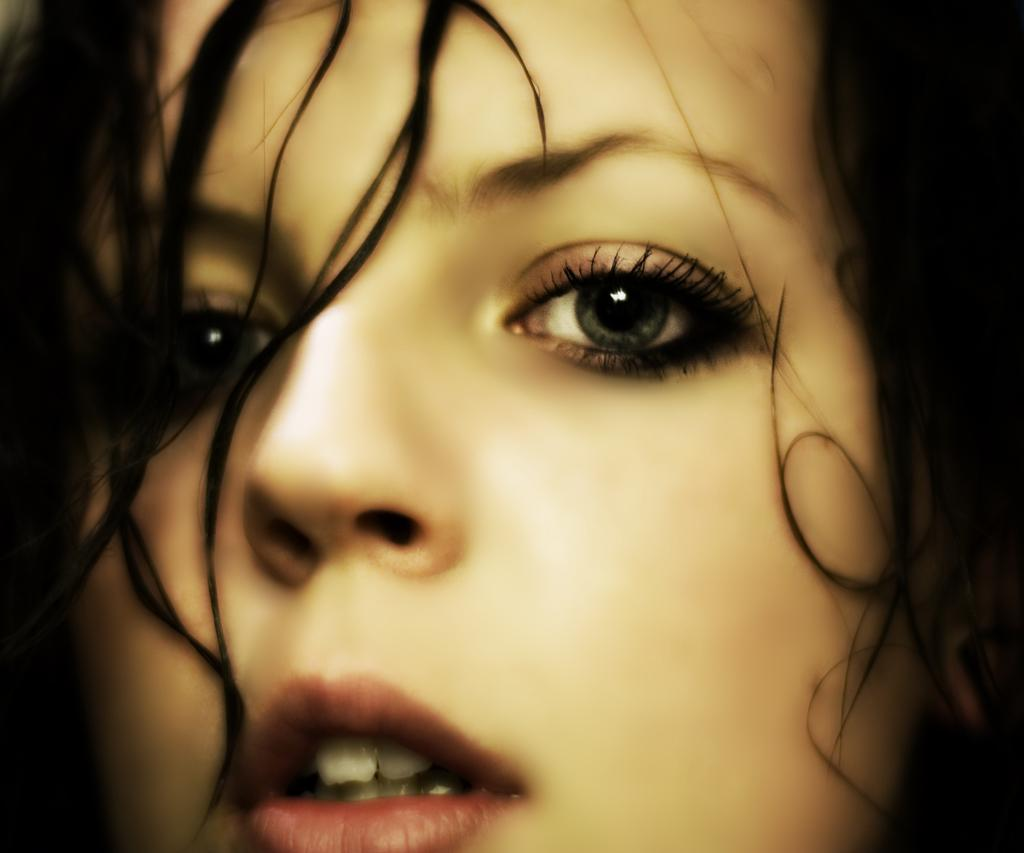What is the main subject of the image? There is a woman's face in the image. What type of quartz is being used to channel the woman's energy in the image? There is no quartz or energy channeling present in the image; it only features a woman's face. 